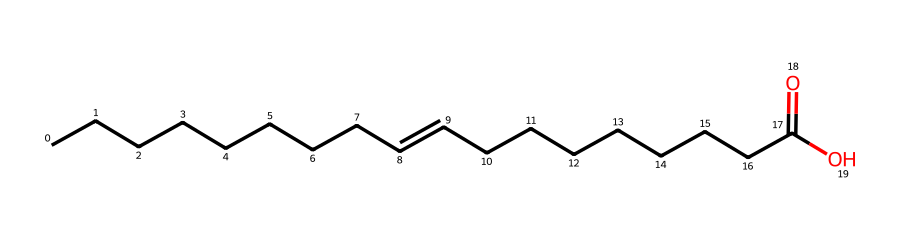What is the total number of carbon atoms in this structure? The SMILES representation indicates a continuous chain of carbon atoms. By counting the "C" characters before and including the carboxylic acid group, we find there are 18 carbon atoms.
Answer: 18 How many double bonds are present in the molecule? The SMILES shows one instance of "=" which indicates a double bond. Counting this reveals that there is a single double bond in the structure.
Answer: 1 What type of functional group is present in this chemical? The structure contains "C(=O)O," which signifies the presence of a carboxylic acid functional group. This specific grouping establishes the acidity and plays a significant role in lubrication.
Answer: carboxylic acid Is this compound likely to be hydrophobic, hydrophilic, or amphiphilic? The presence of a long carbon chain and a carboxylic acid group suggests that the molecule is predominantly hydrophobic due to the lengthy hydrophobic tail, despite the polar carboxylic group.
Answer: hydrophobic What is the primary role of this substance in the context of plant care? As a lubricant, the long carbon chain allows for effective reduction of friction during the operation of pruning shears, while the carboxylic acid contributes to its properties as a lubricant.
Answer: lubricant Would this lipid-derived molecule likely attract animals or insects? Generally, lubrication substances composed primarily of long-chain hydrocarbons tend to be less attractive to most animals or insects. Hence, this compound is likely neutral in terms of attraction.
Answer: neutral 